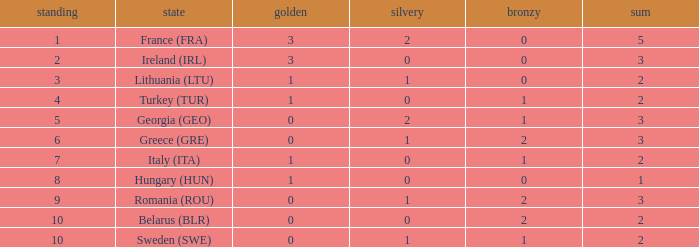What's the total of rank 8 when Silver medals are 0 and gold is more than 1? 0.0. 